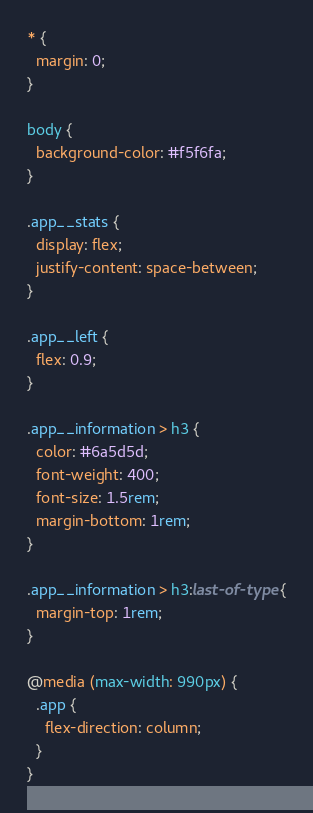Convert code to text. <code><loc_0><loc_0><loc_500><loc_500><_CSS_>* {
  margin: 0;
}

body {
  background-color: #f5f6fa;
}

.app__stats {
  display: flex;
  justify-content: space-between;
}

.app__left {
  flex: 0.9;
}

.app__information > h3 {
  color: #6a5d5d;
  font-weight: 400;
  font-size: 1.5rem;
  margin-bottom: 1rem;
}

.app__information > h3:last-of-type {
  margin-top: 1rem;
}

@media (max-width: 990px) {
  .app {
    flex-direction: column;
  }
}
</code> 